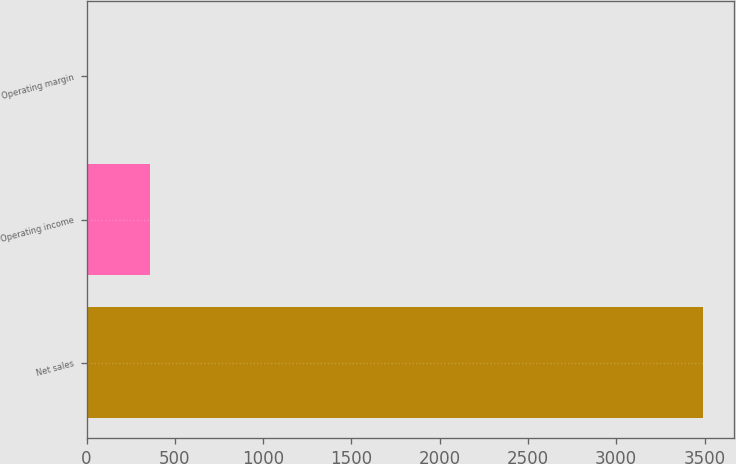Convert chart. <chart><loc_0><loc_0><loc_500><loc_500><bar_chart><fcel>Net sales<fcel>Operating income<fcel>Operating margin<nl><fcel>3491<fcel>357.47<fcel>9.3<nl></chart> 